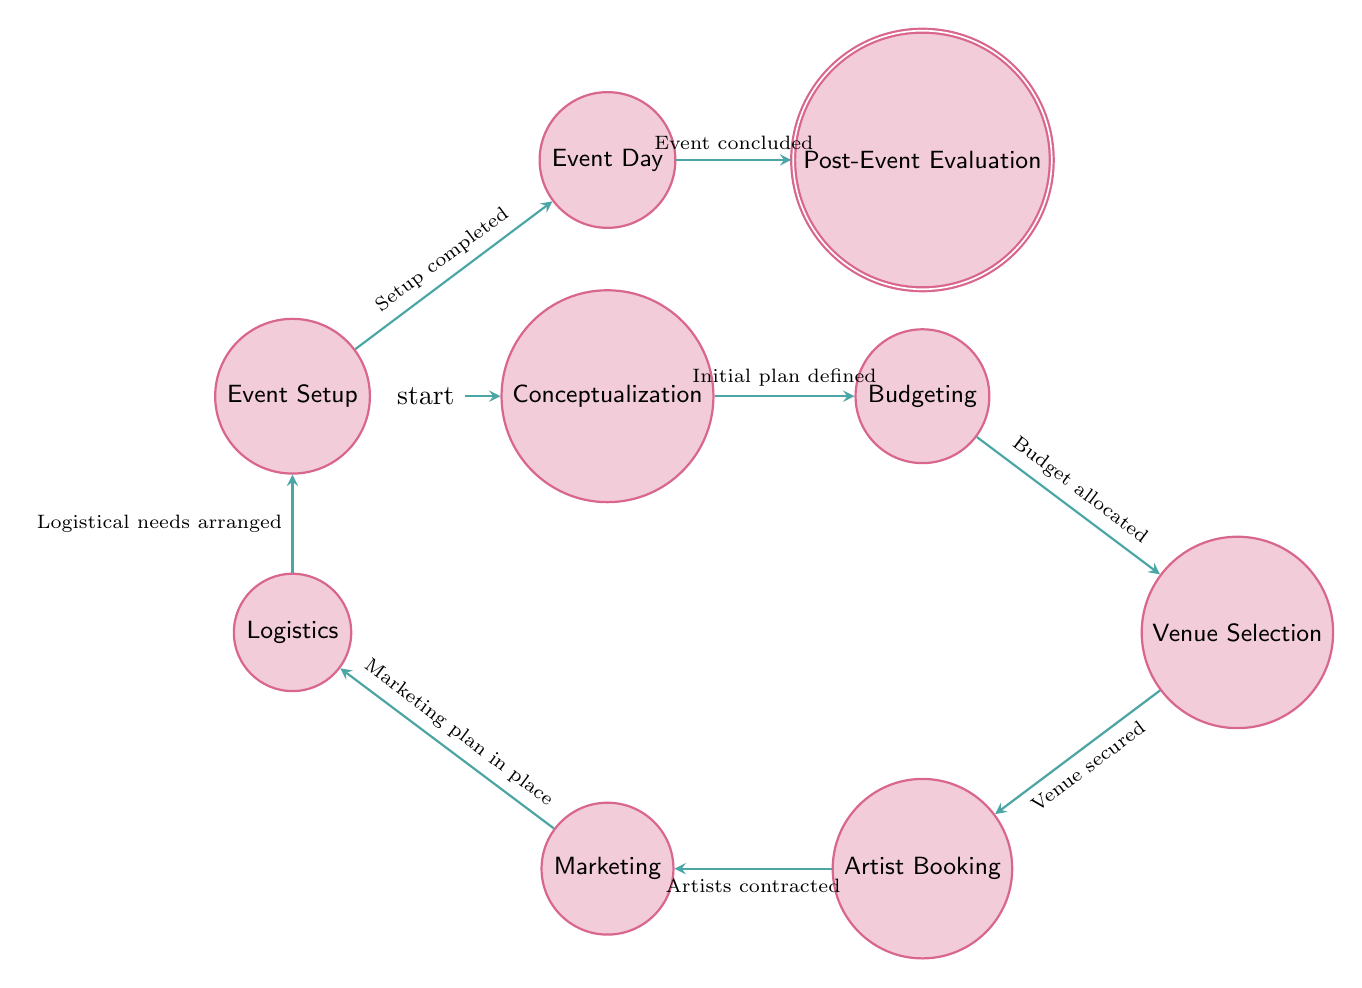What is the first state in the diagram? The initial state in the diagram is labeled as "Conceptualization." This state is indicated by the 'initial' label in the diagram.
Answer: Conceptualization How many states are there in total? Counting all the unique states listed in the diagram, we find nine states: Conceptualization, Budgeting, Venue Selection, Artist Booking, Marketing, Logistics, Event Setup, Event Day, and Post-Event Evaluation.
Answer: Nine What is the last state of the process? The last state in the sequence of the diagram is "Post-Event Evaluation," which represents the final stage of the event planning process.
Answer: Post-Event Evaluation What transition follows after 'Event Setup'? Following 'Event Setup', the next transition leads to 'Event Day'. This transition is represented by an arrow pointing from 'Event Setup' to 'Event Day.'
Answer: Event Day Which state comes after 'Artist Booking'? The state that comes after 'Artist Booking' is 'Marketing,' indicating that marketing efforts begin after artists are contracted.
Answer: Marketing What is the condition to transition from 'Budgeting' to 'Venue Selection'? The condition required to transition from 'Budgeting' to 'Venue Selection' is "Budget allocated for venue," which indicates that funding needs to be established first.
Answer: Budget allocated for venue Describe the flow from 'Logistics' to 'Event Setup'. The flow from 'Logistics' to 'Event Setup' occurs when the condition "Logistical needs arranged" is met, signaling readiness for setup following the logistical arrangements.
Answer: Logistical needs arranged How many transitions are present in the diagram? There are eight transitions illustrated in the diagram, each connecting one state to another along the process of event planning.
Answer: Eight What is the transition condition before 'Marketing'? The transition condition to progress to 'Marketing' is "Artists contracted," which implies that artists must be booked before promoting the festival.
Answer: Artists contracted 